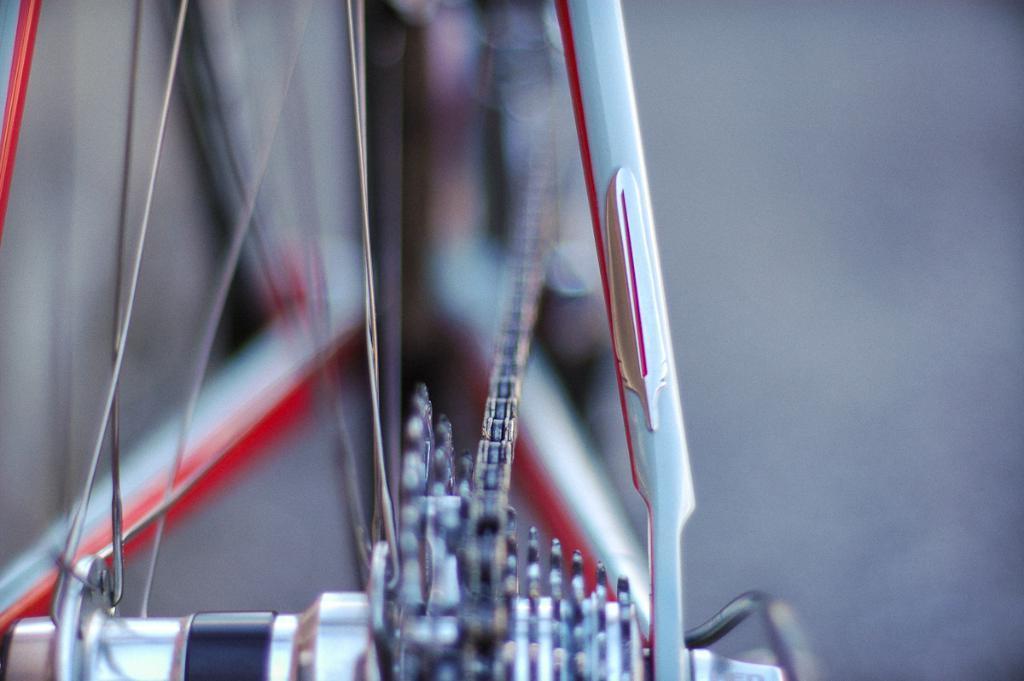In one or two sentences, can you explain what this image depicts? In this image I can see a cycle wheel and chain. Background is blurred. 